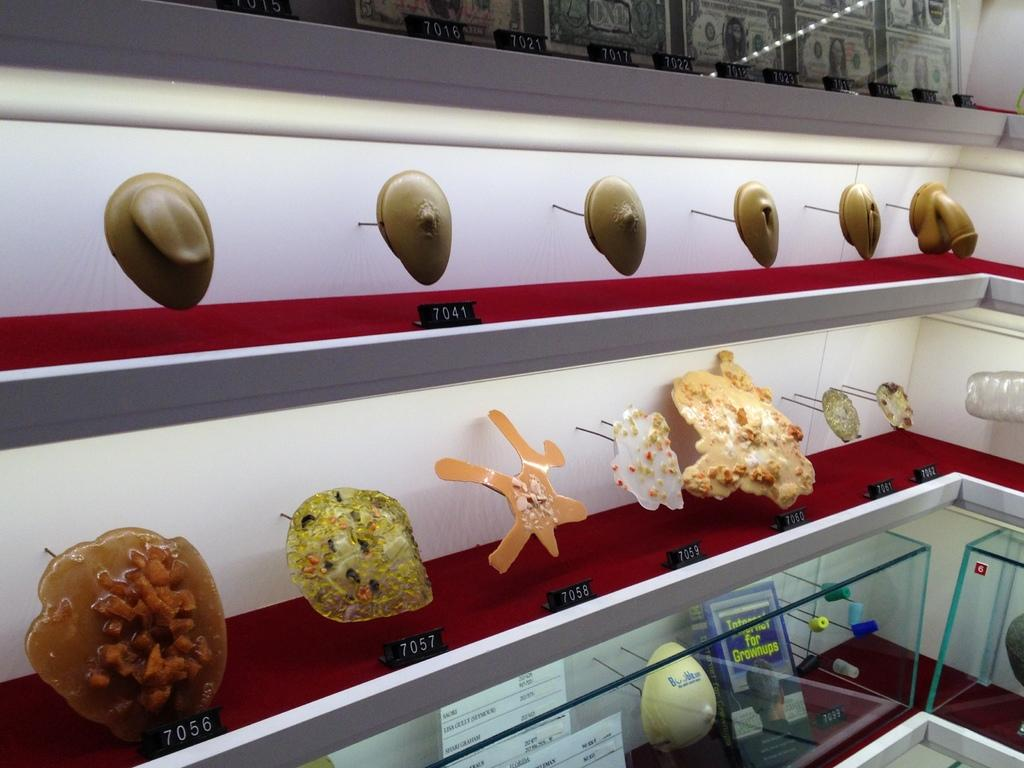What can be seen on the shelves in the image? There are objects on shelves in the image. What material covers the shelves? The shelves are covered with glass. What is the color of the wall above the shelves? There is a white wall above the shelves. Can you see any water droplets on the glass shelves in the image? There is no mention of water droplets on the glass shelves in the provided facts, so we cannot determine their presence from the image. 